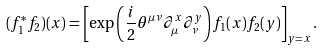Convert formula to latex. <formula><loc_0><loc_0><loc_500><loc_500>( f _ { 1 } ^ { * } f _ { 2 } ) ( x ) = \left [ \exp \left ( \frac { i } { 2 } \theta ^ { \mu \nu } \partial _ { \mu } ^ { x } \partial _ { \nu } ^ { y } \right ) f _ { 1 } ( x ) f _ { 2 } ( y ) \right ] _ { y = x } .</formula> 